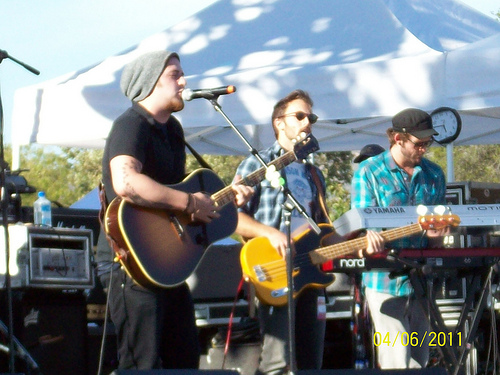<image>
Can you confirm if the bass is to the left of the man? Yes. From this viewpoint, the bass is positioned to the left side relative to the man. 